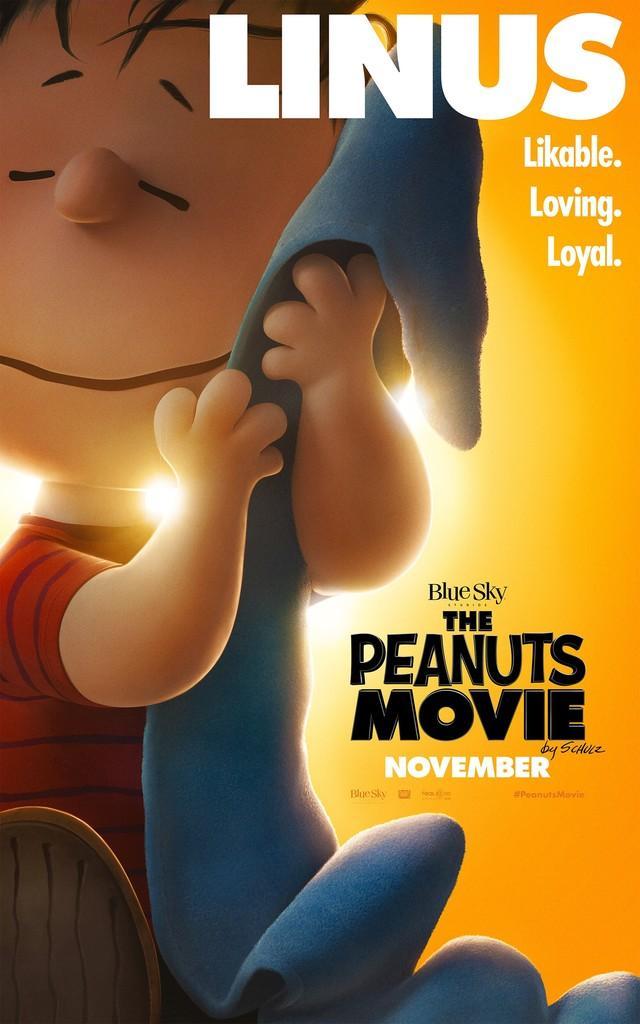Describe this image in one or two sentences. In this image I can see there is an animated image of a boy holding an object and there is something written on the image. 